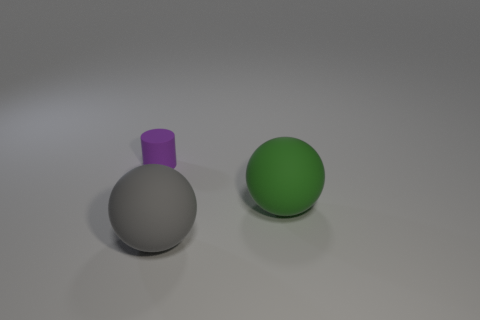Does the sphere that is to the right of the big gray sphere have the same size as the thing that is in front of the large green ball?
Your response must be concise. Yes. How many cylinders are large rubber objects or tiny objects?
Offer a terse response. 1. Is the material of the large sphere that is in front of the large green sphere the same as the small purple object?
Give a very brief answer. Yes. What number of other things are there of the same size as the gray matte object?
Give a very brief answer. 1. What number of small things are either cyan cubes or green spheres?
Your answer should be very brief. 0. Is the number of purple cylinders to the left of the tiny matte cylinder greater than the number of rubber cylinders on the left side of the large green object?
Your answer should be very brief. No. There is a big rubber thing that is behind the big gray rubber thing; is it the same color as the small matte thing?
Provide a short and direct response. No. Is there any other thing that is the same color as the tiny object?
Your answer should be very brief. No. Are there more purple matte things that are behind the large gray matte ball than big gray things?
Keep it short and to the point. No. Is the size of the gray thing the same as the green rubber sphere?
Provide a succinct answer. Yes. 